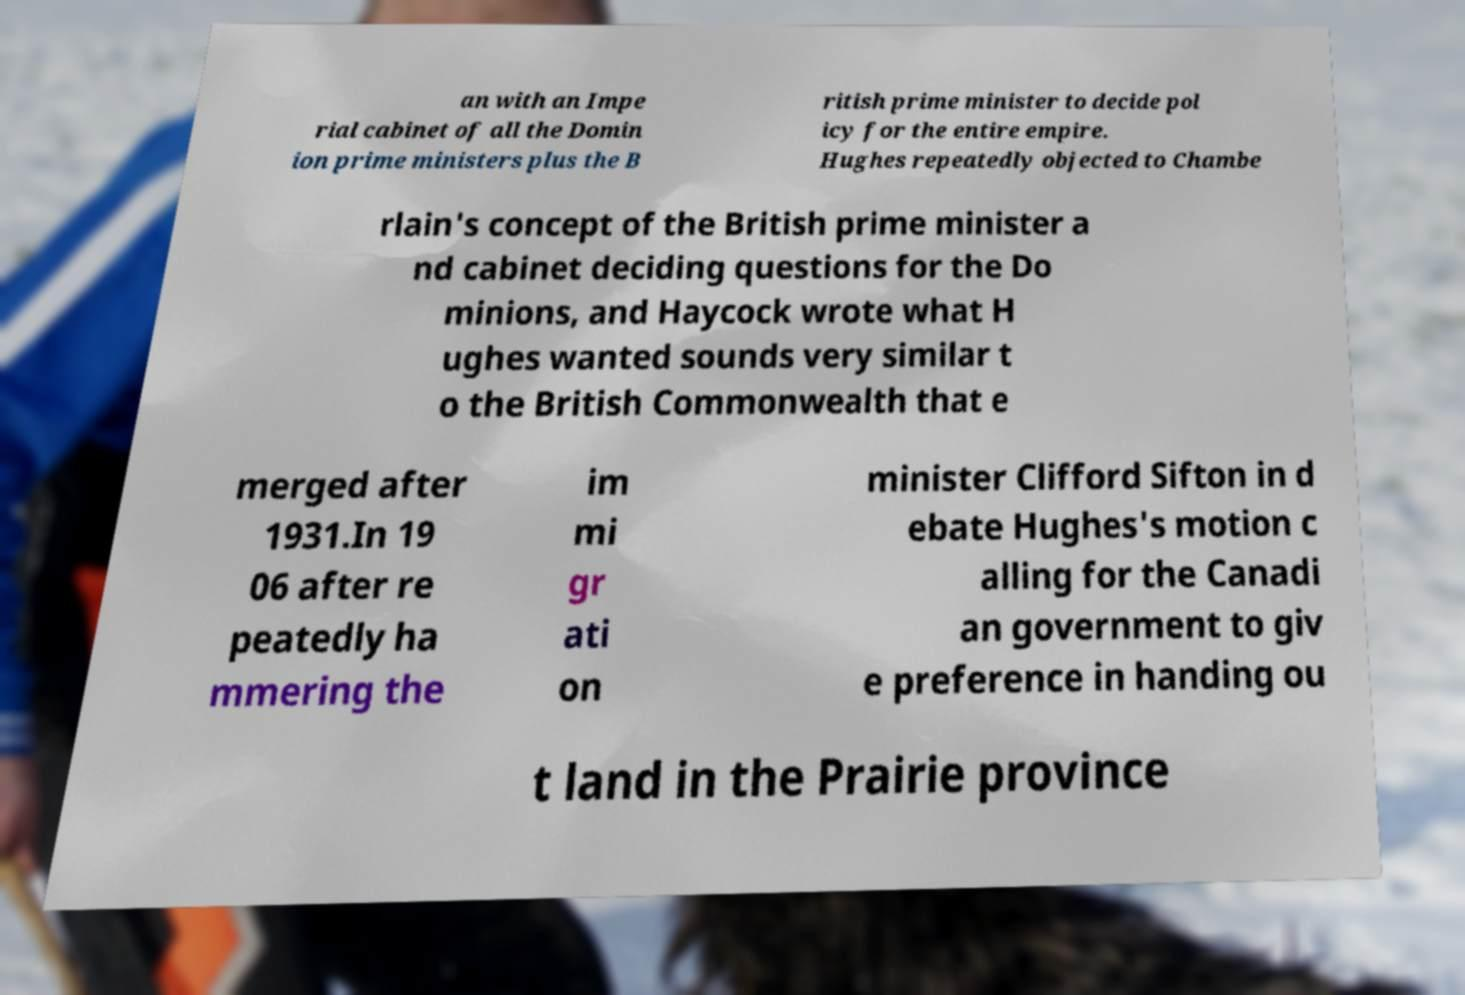There's text embedded in this image that I need extracted. Can you transcribe it verbatim? an with an Impe rial cabinet of all the Domin ion prime ministers plus the B ritish prime minister to decide pol icy for the entire empire. Hughes repeatedly objected to Chambe rlain's concept of the British prime minister a nd cabinet deciding questions for the Do minions, and Haycock wrote what H ughes wanted sounds very similar t o the British Commonwealth that e merged after 1931.In 19 06 after re peatedly ha mmering the im mi gr ati on minister Clifford Sifton in d ebate Hughes's motion c alling for the Canadi an government to giv e preference in handing ou t land in the Prairie province 